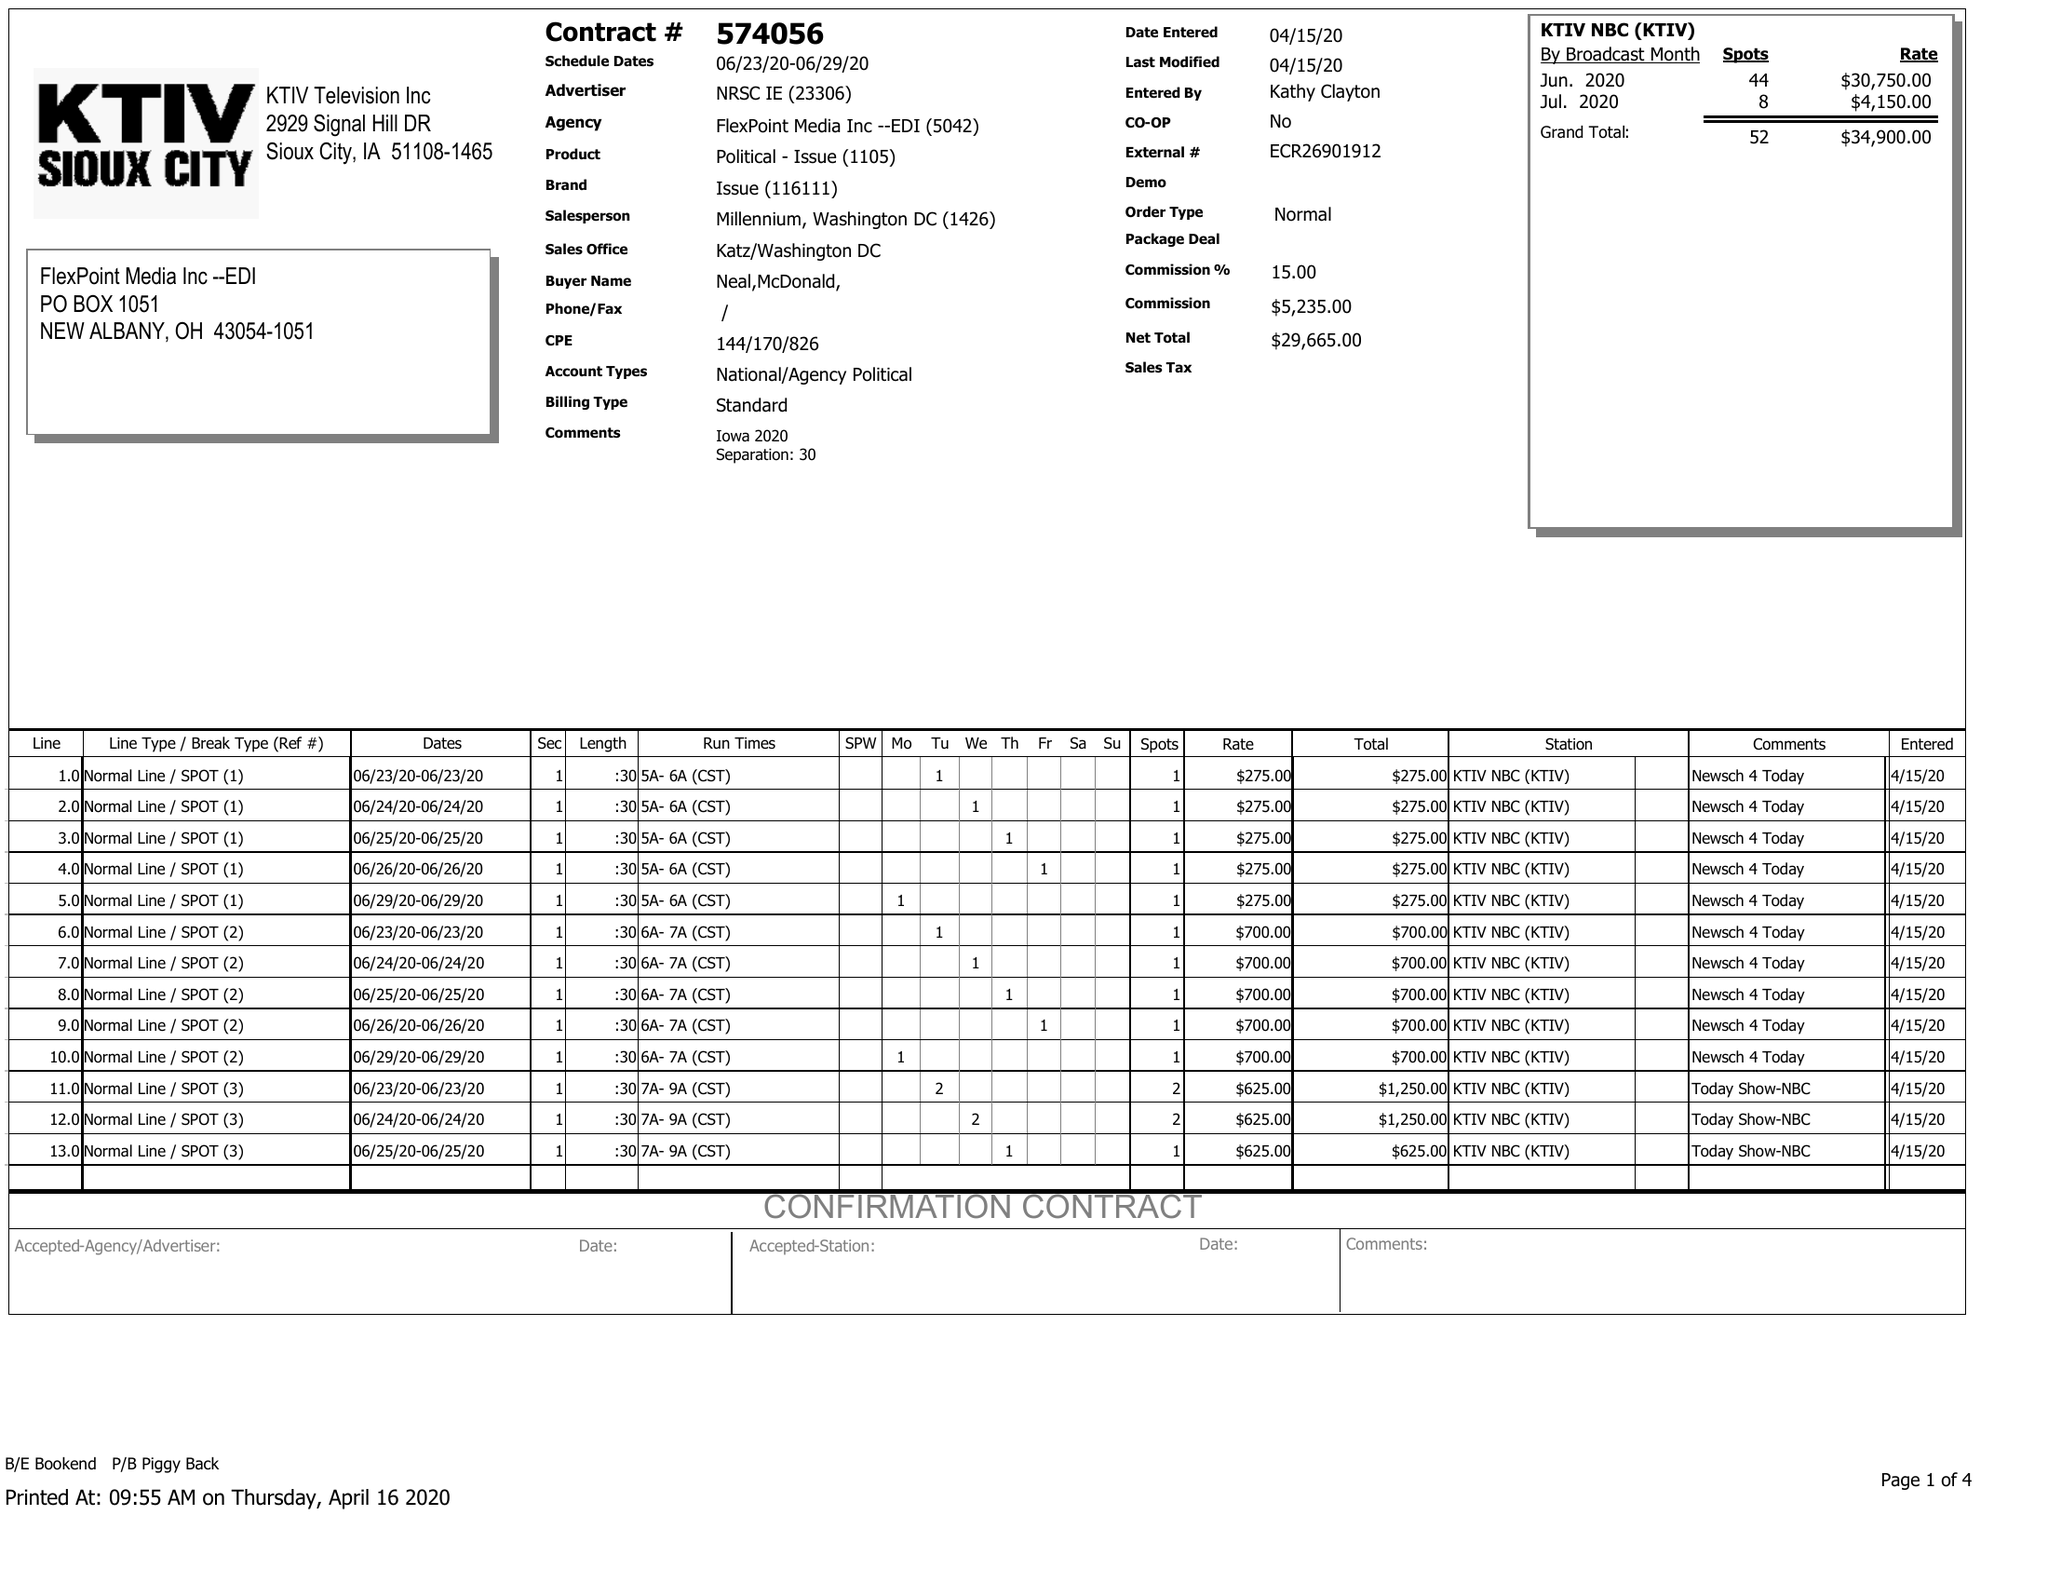What is the value for the contract_num?
Answer the question using a single word or phrase. 574056 